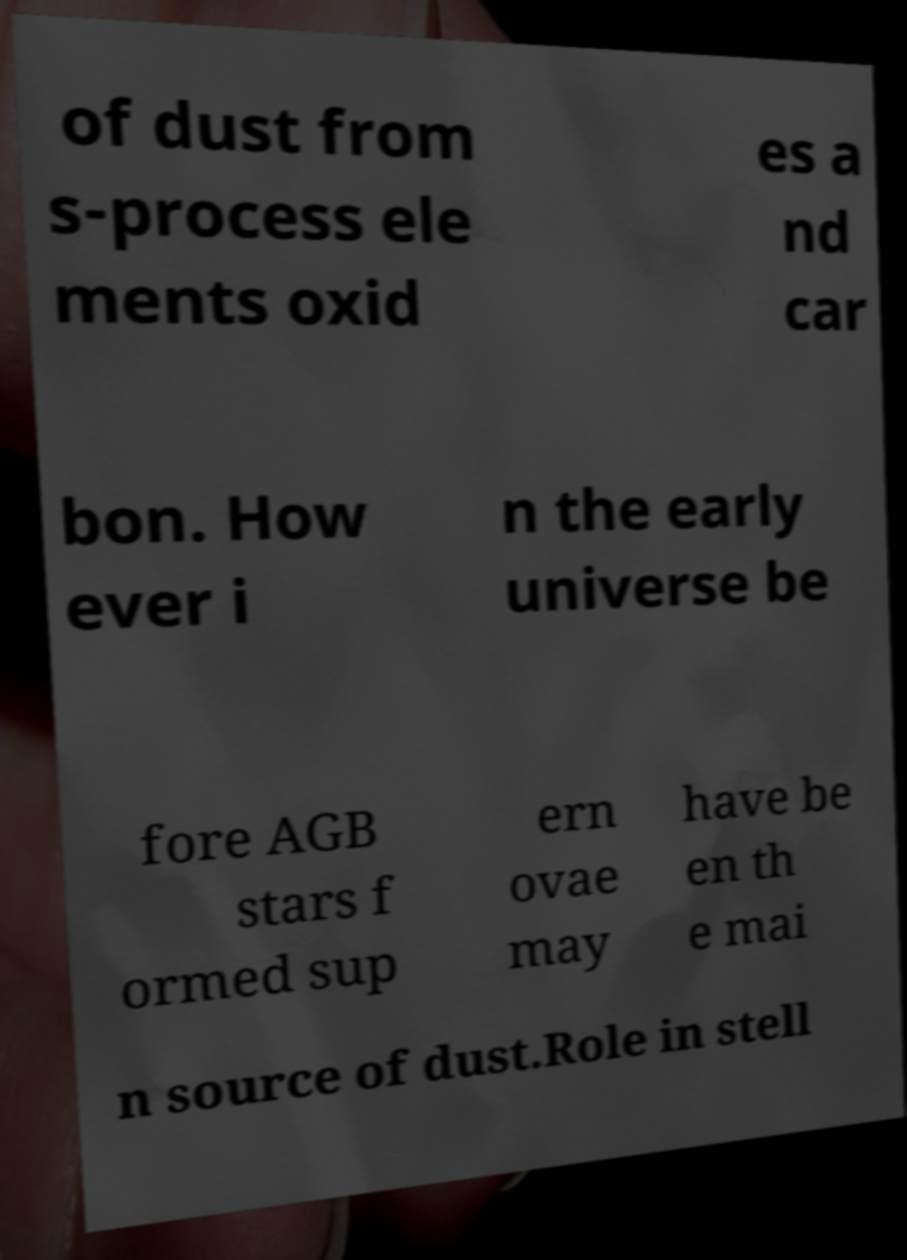What messages or text are displayed in this image? I need them in a readable, typed format. of dust from s-process ele ments oxid es a nd car bon. How ever i n the early universe be fore AGB stars f ormed sup ern ovae may have be en th e mai n source of dust.Role in stell 